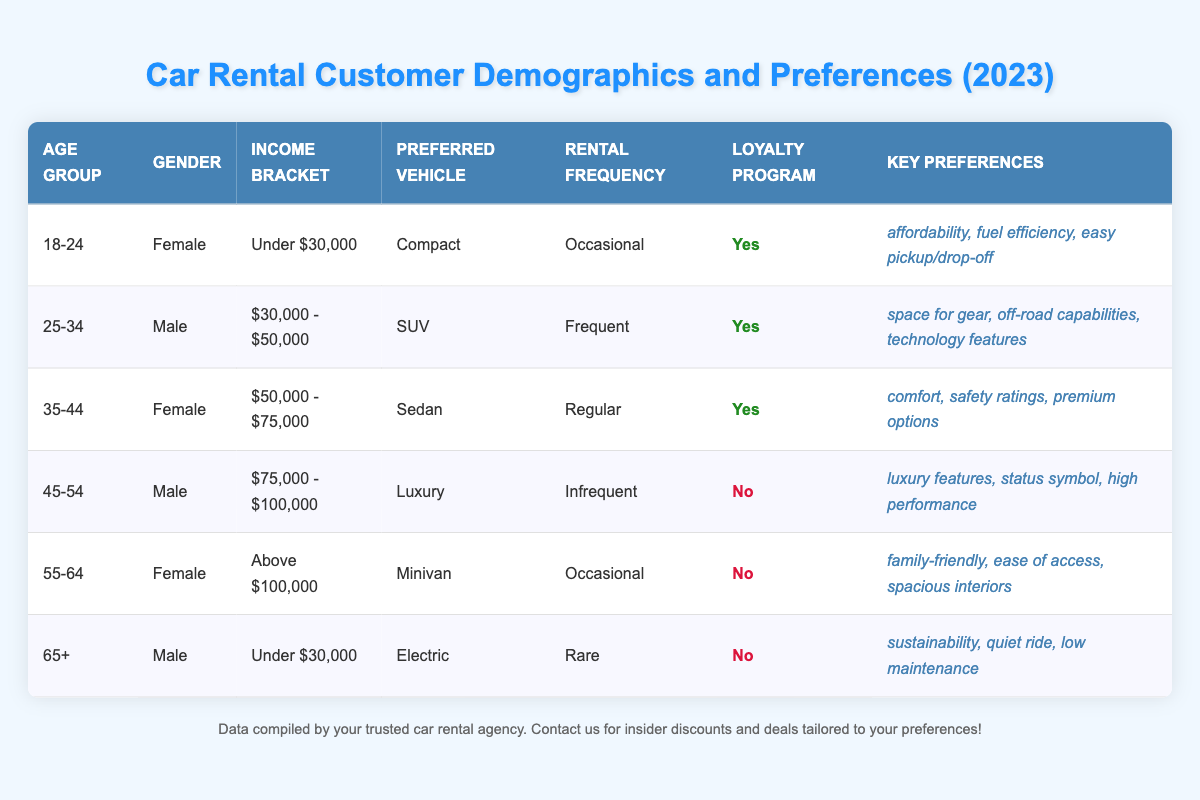What is the preferred vehicle type for customers aged 25-34? In the table, we find the row for the age group 25-34. There, the preferred vehicle type is listed as "SUV."
Answer: SUV How many customers are loyalty program members? By reviewing the table, we see that 4 out of 6 customers are marked as loyalty program members (18-24, 25-34, 35-44).
Answer: 4 What is the income bracket of the customer who prefers a luxury vehicle? Looking at the row for the luxury vehicle, the income bracket is "$75,000 - $100,000."
Answer: $75,000 - $100,000 Which vehicle type has the highest preference among customers? The preferred vehicle types listed are Compact, SUV, Sedan, Luxury, Minivan, and Electric. The SUV is preferred by the customer who rents frequently (25-34), while the Compact is preferred by those who rent occasionally (18-24). There isn't a single type that can be determined as the "highest preference," but based on rental frequency, the SUV stands out as highly preferred.
Answer: SUV Are there any customers aged 65 and over who are loyalty program members? In the table, the 65+ age group is the only customer listed as not being a loyalty program member. Therefore, there are no customers aged 65 and over who are loyalty members.
Answer: No What is the average income bracket of customers who prefer family-friendly vehicles? The only customer preferring family-friendly vehicles (Minivan) has an income bracket of "Above $100,000." Since there's only one customer in this category, the average is the same as this income bracket.
Answer: Above $100,000 Which gender has the highest number of loyalty program members? Analyzing the loyalty program membership, we count 3 females (18-24, 35-44, and 55-64) and 1 male (25-34) among the loyalty members. Therefore, more females are loyalty members.
Answer: Female What are the key preferences of the customer who rents an electric vehicle? For the customer aged 65+, who prefers the electric vehicle, the key preferences listed are "sustainability, quiet ride, low maintenance."
Answer: sustainability, quiet ride, low maintenance What is the difference in rental frequency between the youngest and oldest customer groups? The youngest group (18-24) has an "Occasional" rental frequency, while the oldest group (65+) has a "Rare" rental frequency. The difference indicates younger customers are more likely to rent compared to the older group.
Answer: Occasional - Rare Is it true that all high-income customers prefer luxury vehicles? There are two high-income brackets: "Above $100,000" and "$75,000 - $100,000." The customer in the "$75,000 - $100,000" bracket prefers a luxury vehicle, while the "Above $100,000" customer prefers a minivan. Hence, it’s false that all high-income customers prefer luxury vehicles.
Answer: No 